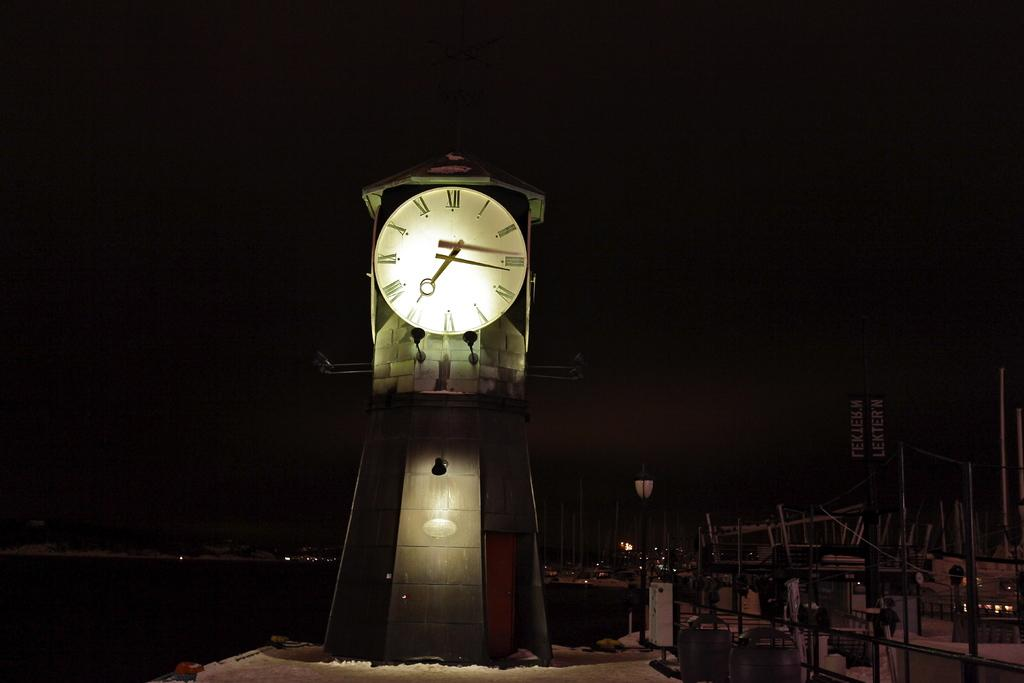<image>
Provide a brief description of the given image. A tower clock that shows the approximate time of 7:15. 